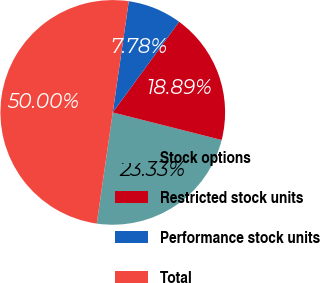Convert chart to OTSL. <chart><loc_0><loc_0><loc_500><loc_500><pie_chart><fcel>Stock options<fcel>Restricted stock units<fcel>Performance stock units<fcel>Total<nl><fcel>23.33%<fcel>18.89%<fcel>7.78%<fcel>50.0%<nl></chart> 